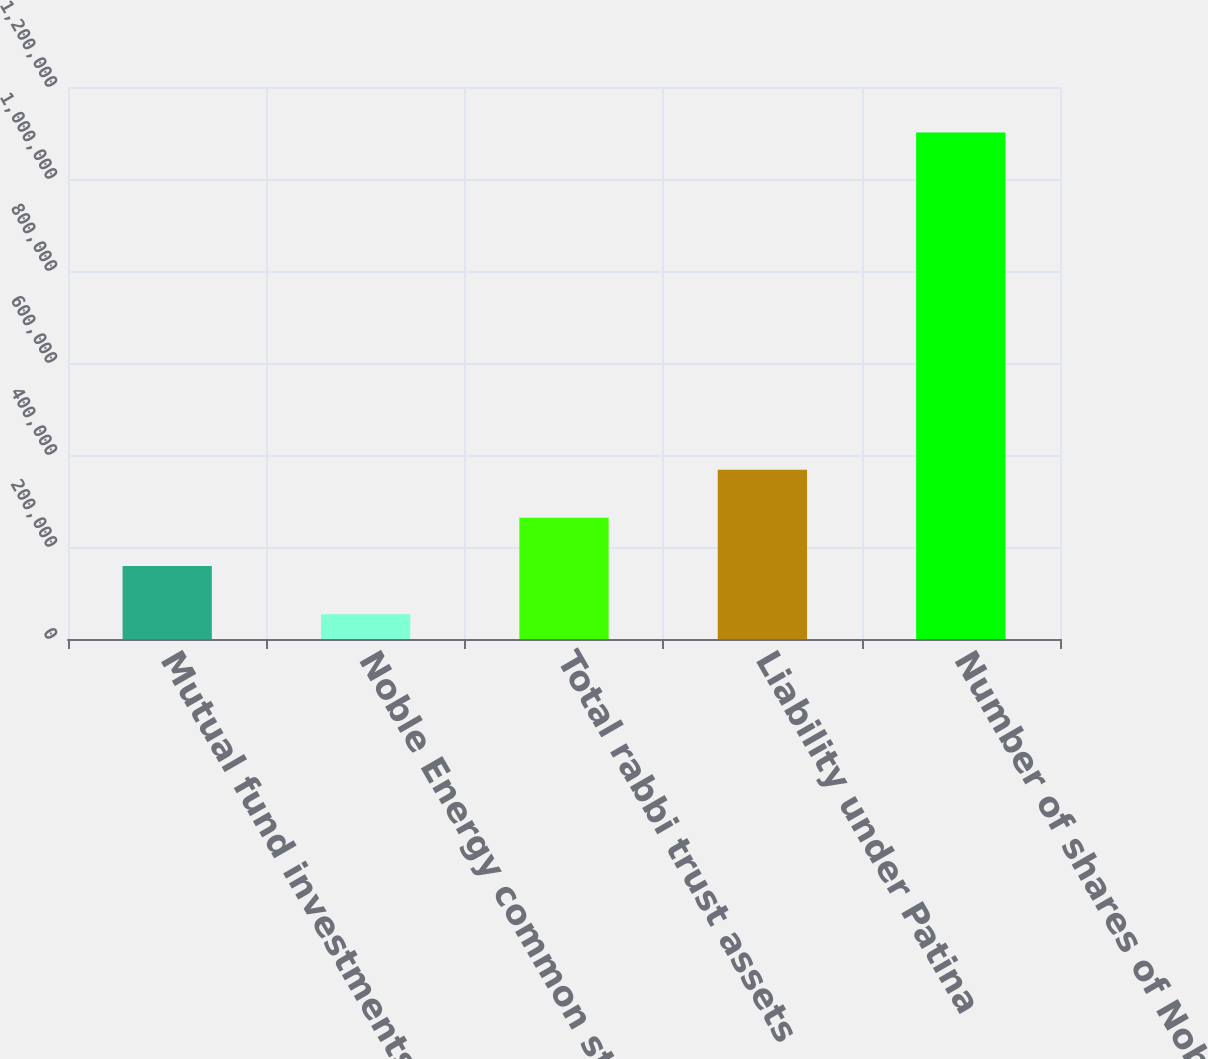<chart> <loc_0><loc_0><loc_500><loc_500><bar_chart><fcel>Mutual fund investments<fcel>Noble Energy common stock (at<fcel>Total rabbi trust assets<fcel>Liability under Patina<fcel>Number of shares of Noble<nl><fcel>158728<fcel>54027<fcel>263428<fcel>368128<fcel>1.10103e+06<nl></chart> 